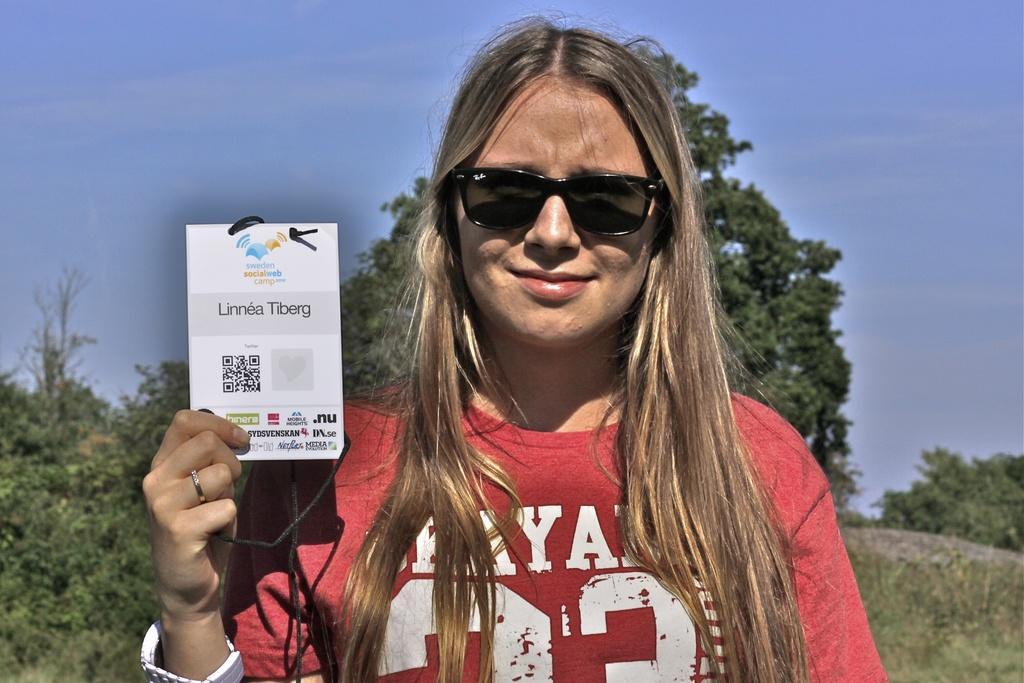How would you summarize this image in a sentence or two? This picture is clicked outside. In the foreground we can see a woman wearing t-shirt, holding a white color object, smiling and standing. In the background we can see the sky, trees, plants and the grass and we can see some other items. 